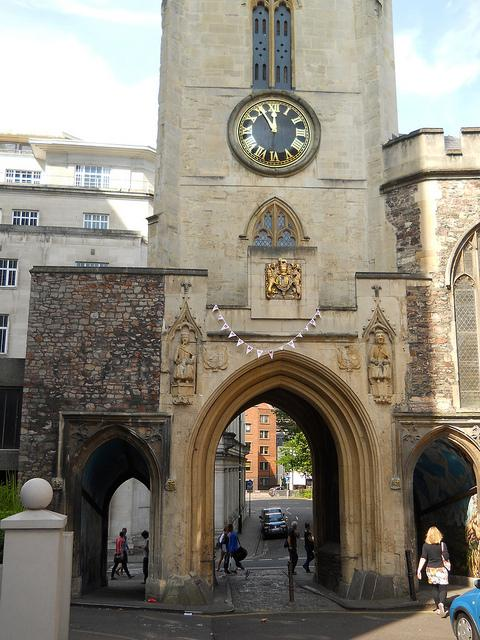What numeral system is used on the clock?

Choices:
A) egyptian
B) greek
C) roman
D) digital roman 